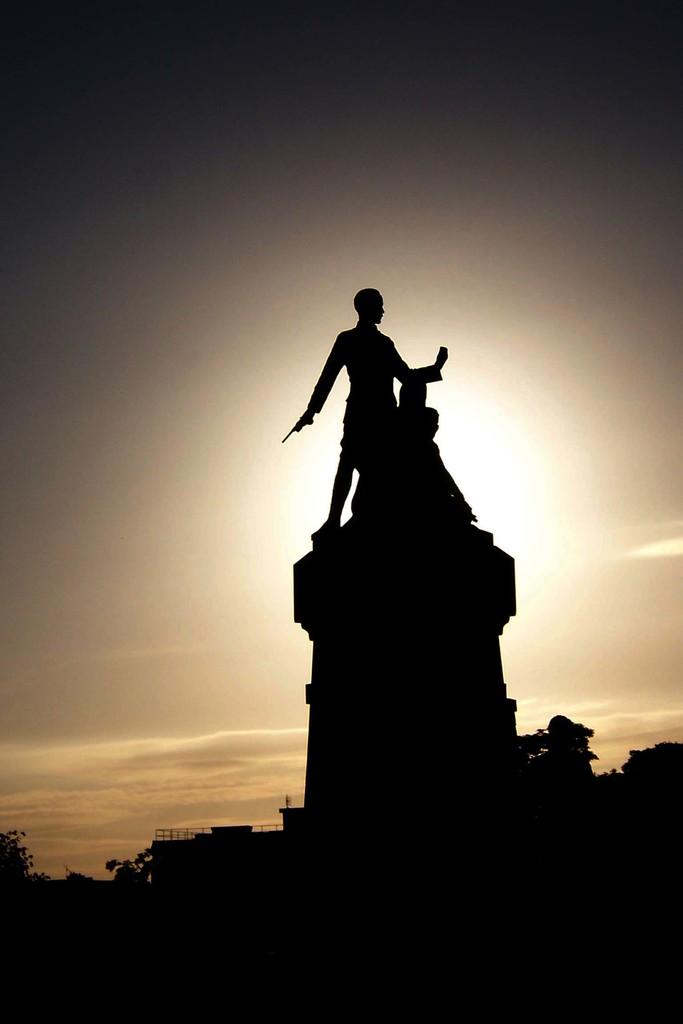What can be seen in the image besides the sky and trees? There are two statues of persons in the image. What type of vegetation is visible in the background? There are trees in the background of the image. How would you describe the color of the sky in the image? The sky is described as white and gray in the image. Can you see any bubbles in the image? There are no bubbles present in the image. What happens when the statues smash into each other in the image? The statues do not smash into each other in the image; they are stationary. 